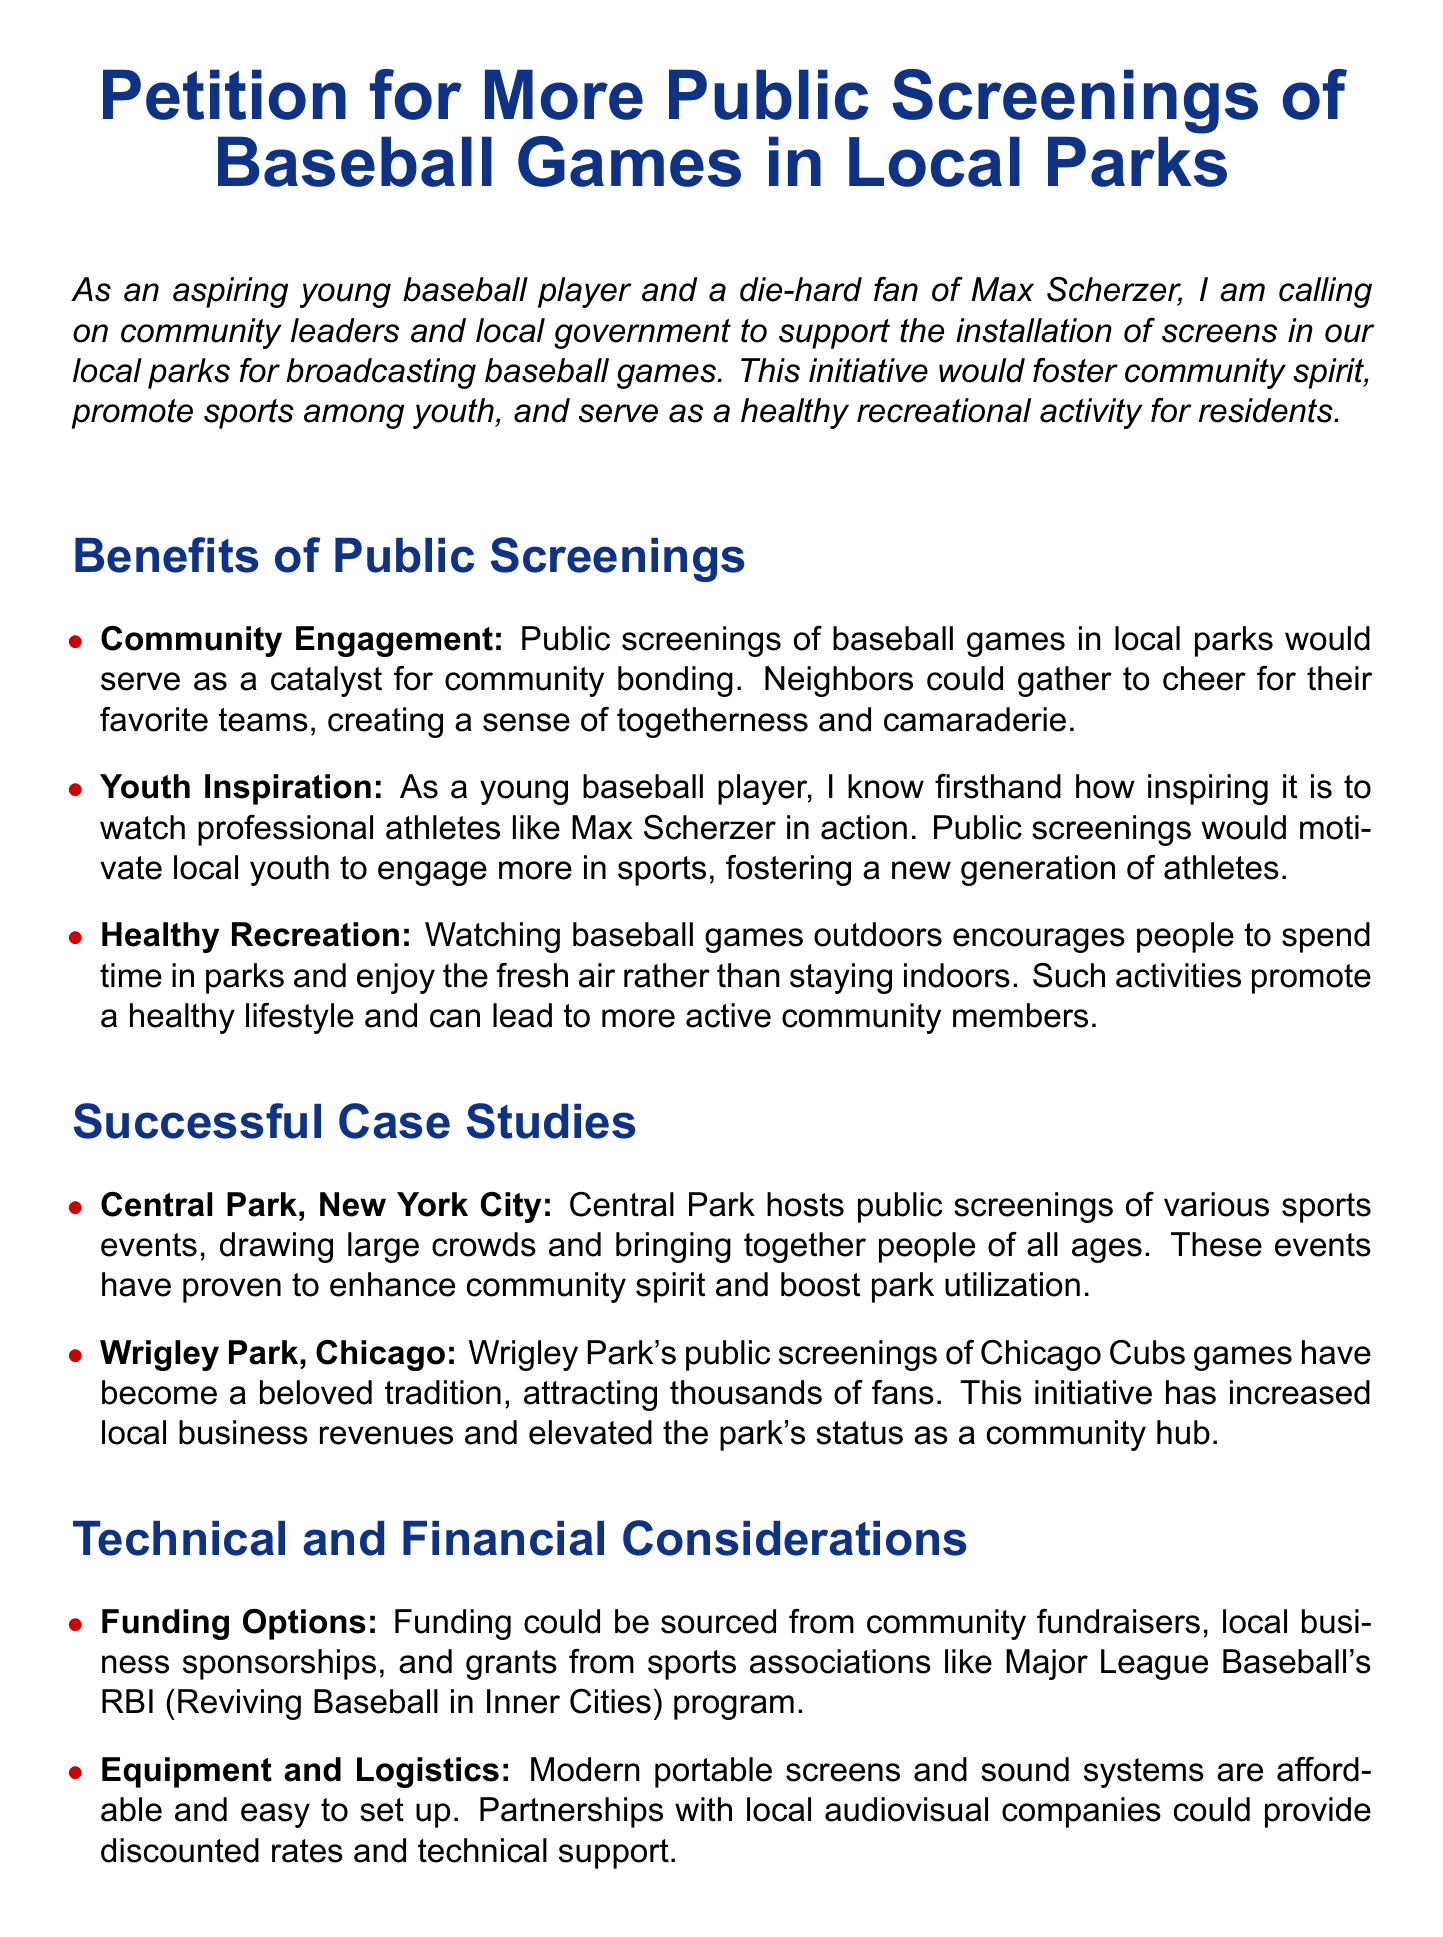What is the title of the petition? The title of the petition is clearly stated at the top of the document.
Answer: Petition for More Public Screenings of Baseball Games in Local Parks Who is the target group for the petition? The petition specifically calls on community leaders and local government for support.
Answer: Community leaders and local government What benefit promotes community bonding? The document lists the benefits of public screenings, highlighting how they foster togetherness.
Answer: Community Engagement Which parks are cited as successful case studies? The document names specific parks where public screenings have been successful.
Answer: Central Park, Wrigley Park What is a suggested funding source mentioned in the petition? The petition lists potential funding sources that could support the initiative.
Answer: Local business sponsorships How does the petition propose to ensure safety measures? The document outlines the planning required for ensuring safety during public screenings.
Answer: Proper planning What date format is requested for signatures? The document shows where individuals are asked to fill in their signature and date.
Answer: Date: How are local businesses expected to benefit from the initiative? The successful case studies suggest local businesses may see an increase in revenues.
Answer: Increased local business revenues What color theme is used in the document for titles? The document uses a specific color to highlight section titles throughout.
Answer: Baseball blue 